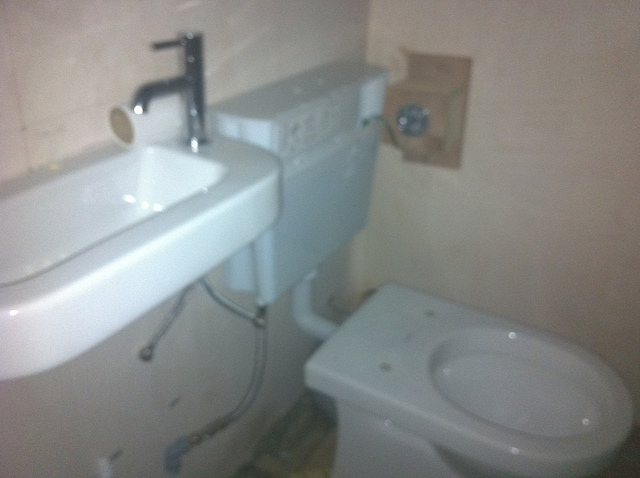Is this a new bathroom?
Answer the question using a single word or phrase. No Is there a mirror? No Is this bathroom clean? Yes Is there a toilet seat on the toilet? No 